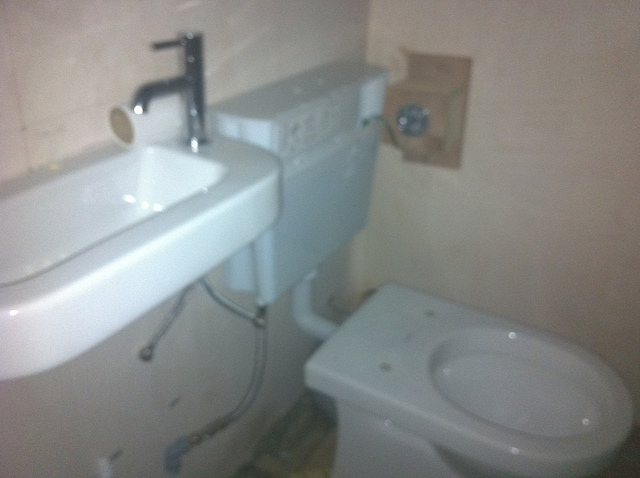Is this a new bathroom?
Answer the question using a single word or phrase. No Is there a mirror? No Is this bathroom clean? Yes Is there a toilet seat on the toilet? No 